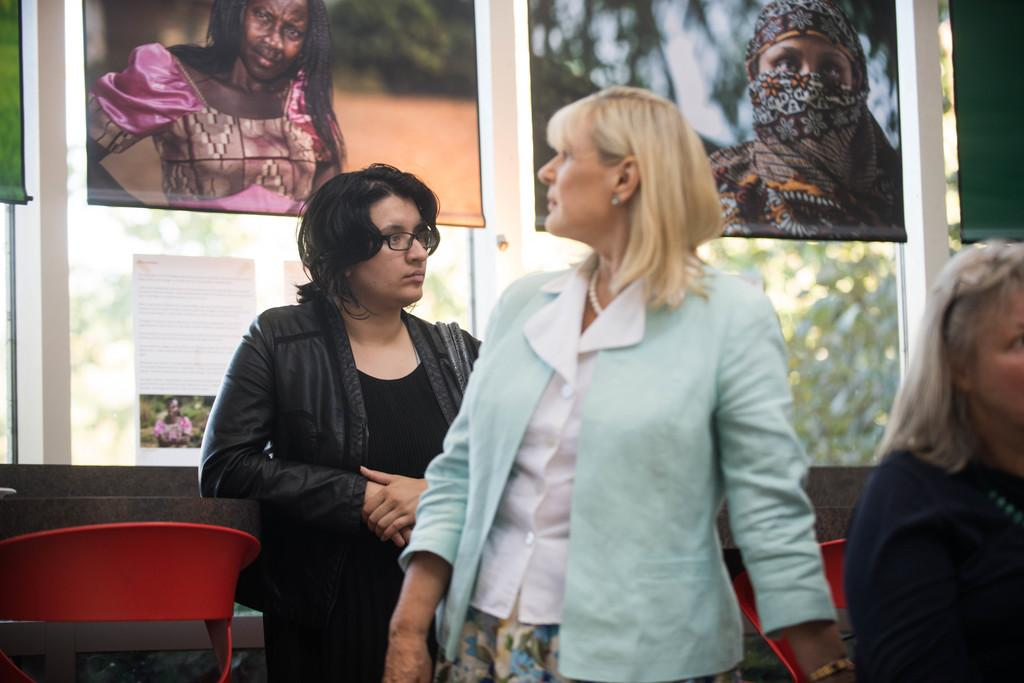How many women are present in the image? There are three women in the image. What is the position of one of the women? One woman is sitting on a chair. How many chairs are visible in the image? There are two chairs in the image. What can be seen in the background of the image? There is a glass door, a curtain, and a tree visible in the background. What type of kitten can be seen playing with a map in the image? There is no kitten or map present in the image. What class are the women attending in the image? There is no indication of a class or any educational setting in the image. 